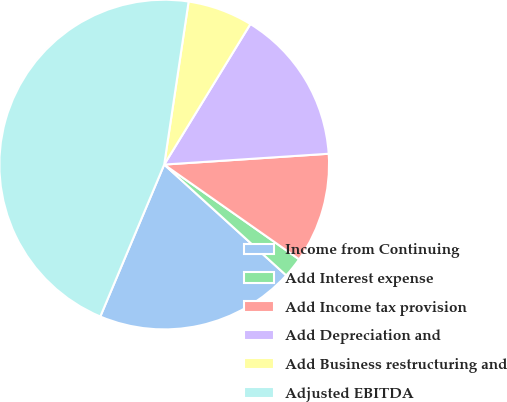Convert chart to OTSL. <chart><loc_0><loc_0><loc_500><loc_500><pie_chart><fcel>Income from Continuing<fcel>Add Interest expense<fcel>Add Income tax provision<fcel>Add Depreciation and<fcel>Add Business restructuring and<fcel>Adjusted EBITDA<nl><fcel>19.6%<fcel>1.99%<fcel>10.79%<fcel>15.2%<fcel>6.39%<fcel>46.03%<nl></chart> 